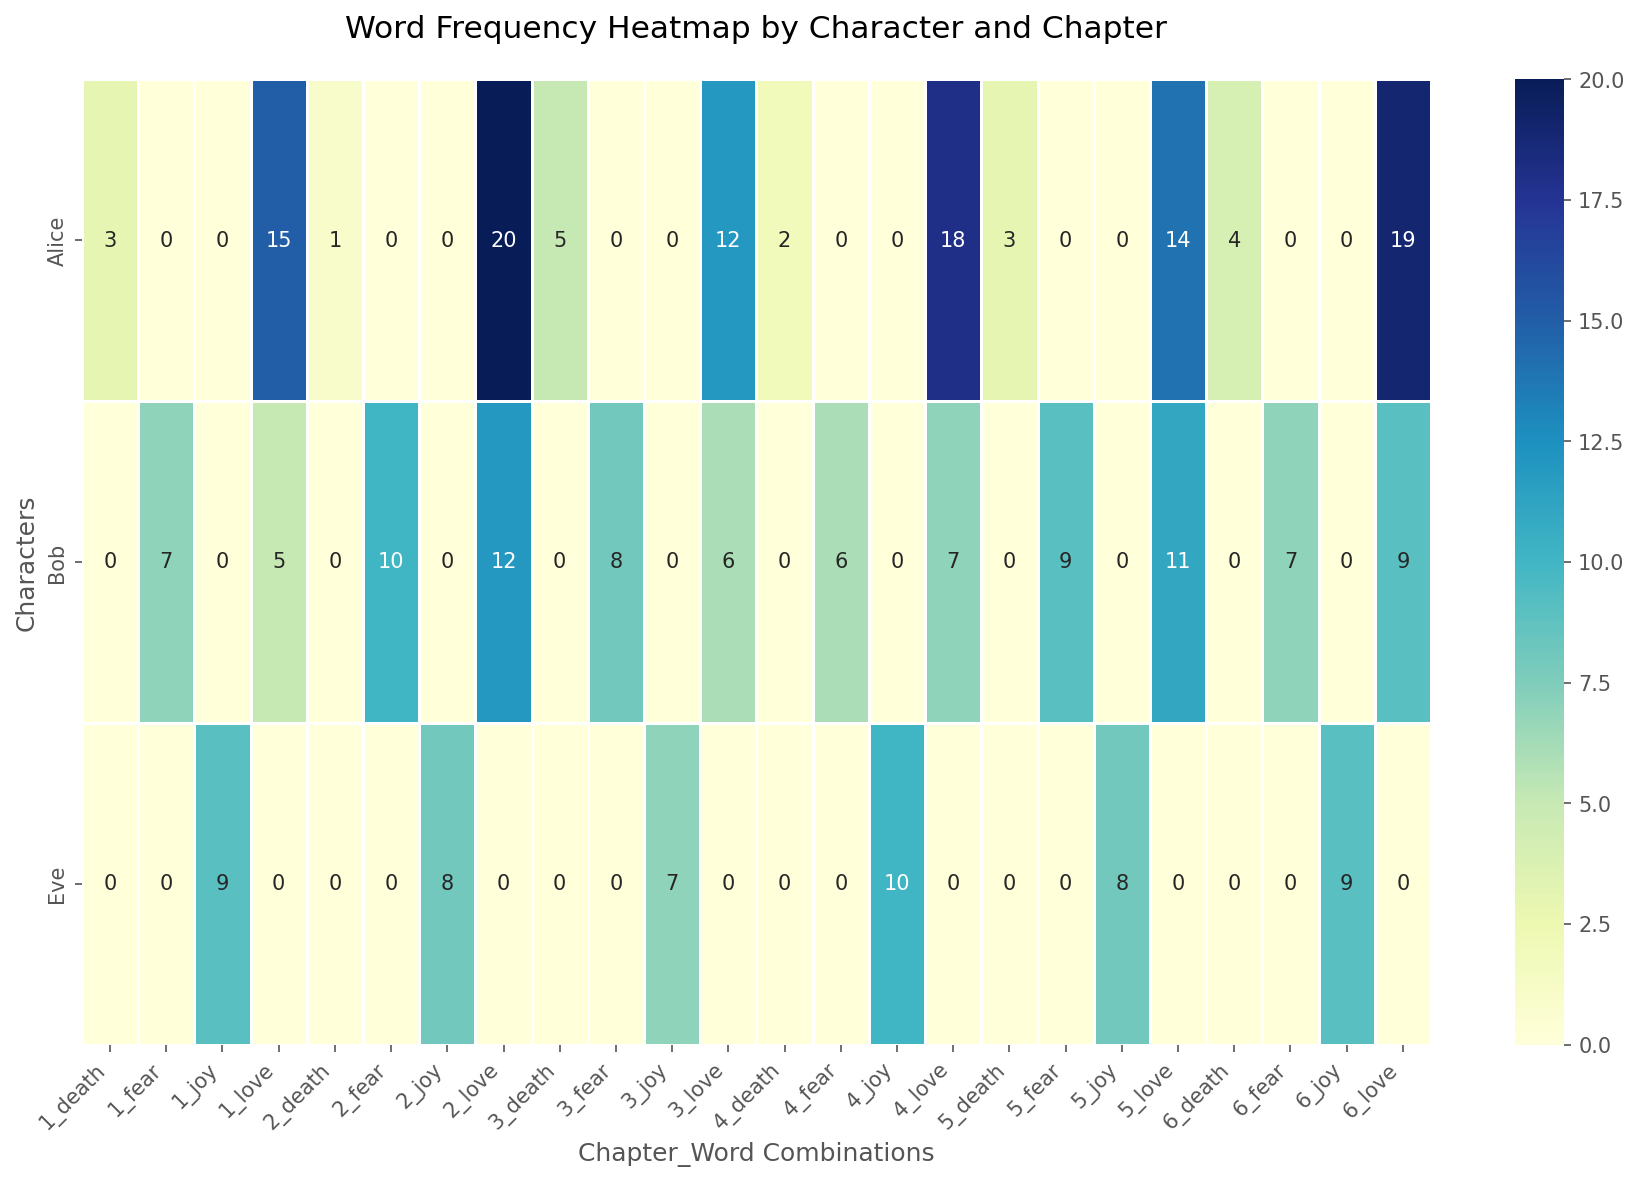What is the total frequency of the word 'love' in Chapter 3 across all characters? To get the total frequency of the word 'love' in Chapter 3, check the heatmap values associated with 'love' in Chapter 3 across all characters. Add these frequencies together. For Alice, it's 12; for Bob, it's 6, and for Eve, no data is given for 'love'. So, the total is 12 + 6 = 18.
Answer: 18 Which character has the highest frequency of the word 'death' in Chapter 1? Look at the heatmap values for the word 'death' in Chapter 1 for all characters. Alice has a frequency of 3 and Bob has no data for 'death' in Chapter 1. Comparing the frequencies, Alice has the highest frequency of 3.
Answer: Alice Is the frequency of the word 'fear' higher in Chapter 2 or Chapter 5 for Bob? Compare the frequencies of the word 'fear' for Bob in Chapter 2 and Chapter 5. In Chapter 2, the frequency is 10, and in Chapter 5, it is 9. Therefore, the frequency is higher in Chapter 2.
Answer: Chapter 2 What is the average frequency of the word 'joy' for Eve across all chapters? To find the average frequency, add up the 'joy' frequencies for Eve across Chapters 1 to 6 and then divide by the number of chapters. The frequencies are 9, 8, 7, 10, 8, and 9. The total is 9 + 8 + 7 + 10 + 8 + 9 = 51. Divide by 6: 51/6 ≈ 8.5.
Answer: 8.5 Which chapter has the most occurrences of the word 'love' across all characters? Check the heatmap for the frequencies of the word 'love' across all characters for each chapter. Sum the frequencies for each chapter: Chapter 1 (15+5), Chapter 2 (20+12), Chapter 3 (12+6), Chapter 4 (18+7), Chapter 5 (14+11), Chapter 6 (19+9). Calculations: Chapter 1: 20, Chapter 2: 32, Chapter 3: 18, Chapter 4: 25, Chapter 5: 25, Chapter 6: 28. Thus, Chapter 2 has the most occurrences with 32.
Answer: Chapter 2 Does Alice or Bob have a higher total frequency of all words combined in Chapter 4? Check the heatmap for Alice and Bob's word frequencies in Chapter 4. Sum Alice's frequencies (18 'love' and 2 'death') and Bob's frequencies (6 'fear' and 7 'love'). Alice's total: 18 + 2 = 20. Bob's total: 6 + 7 = 13. Alice has a higher total frequency.
Answer: Alice 